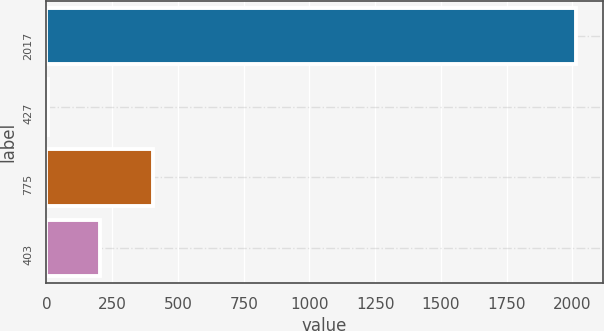Convert chart. <chart><loc_0><loc_0><loc_500><loc_500><bar_chart><fcel>2017<fcel>427<fcel>775<fcel>403<nl><fcel>2015<fcel>4.14<fcel>406.32<fcel>205.23<nl></chart> 